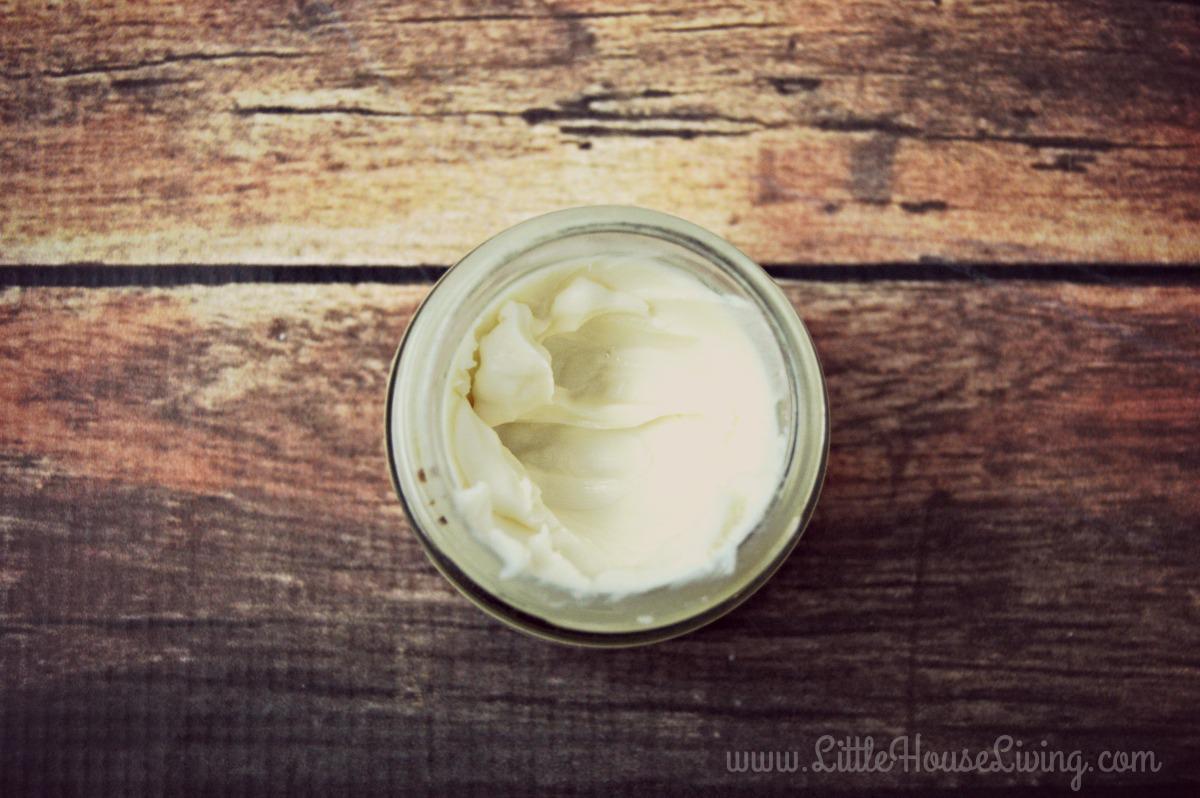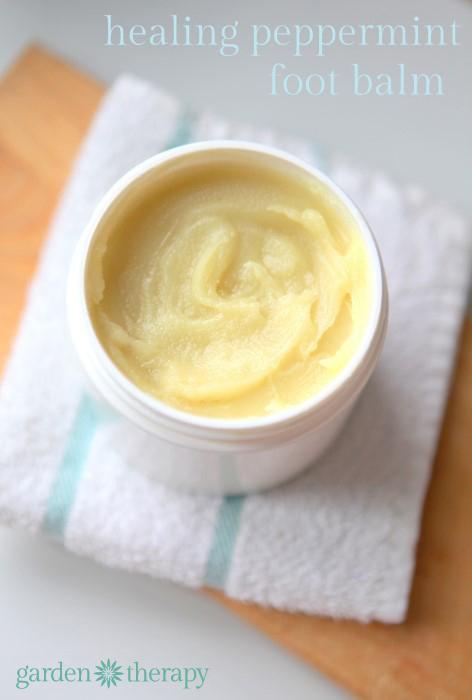The first image is the image on the left, the second image is the image on the right. Evaluate the accuracy of this statement regarding the images: "A silver lid is resting against a container in the image on the right.". Is it true? Answer yes or no. No. The first image is the image on the left, the second image is the image on the right. Assess this claim about the two images: "Each image shows one open jar filled with a creamy substance, and in one image, a silver lid is leaning at any angle against the edge of the jar.". Correct or not? Answer yes or no. No. 